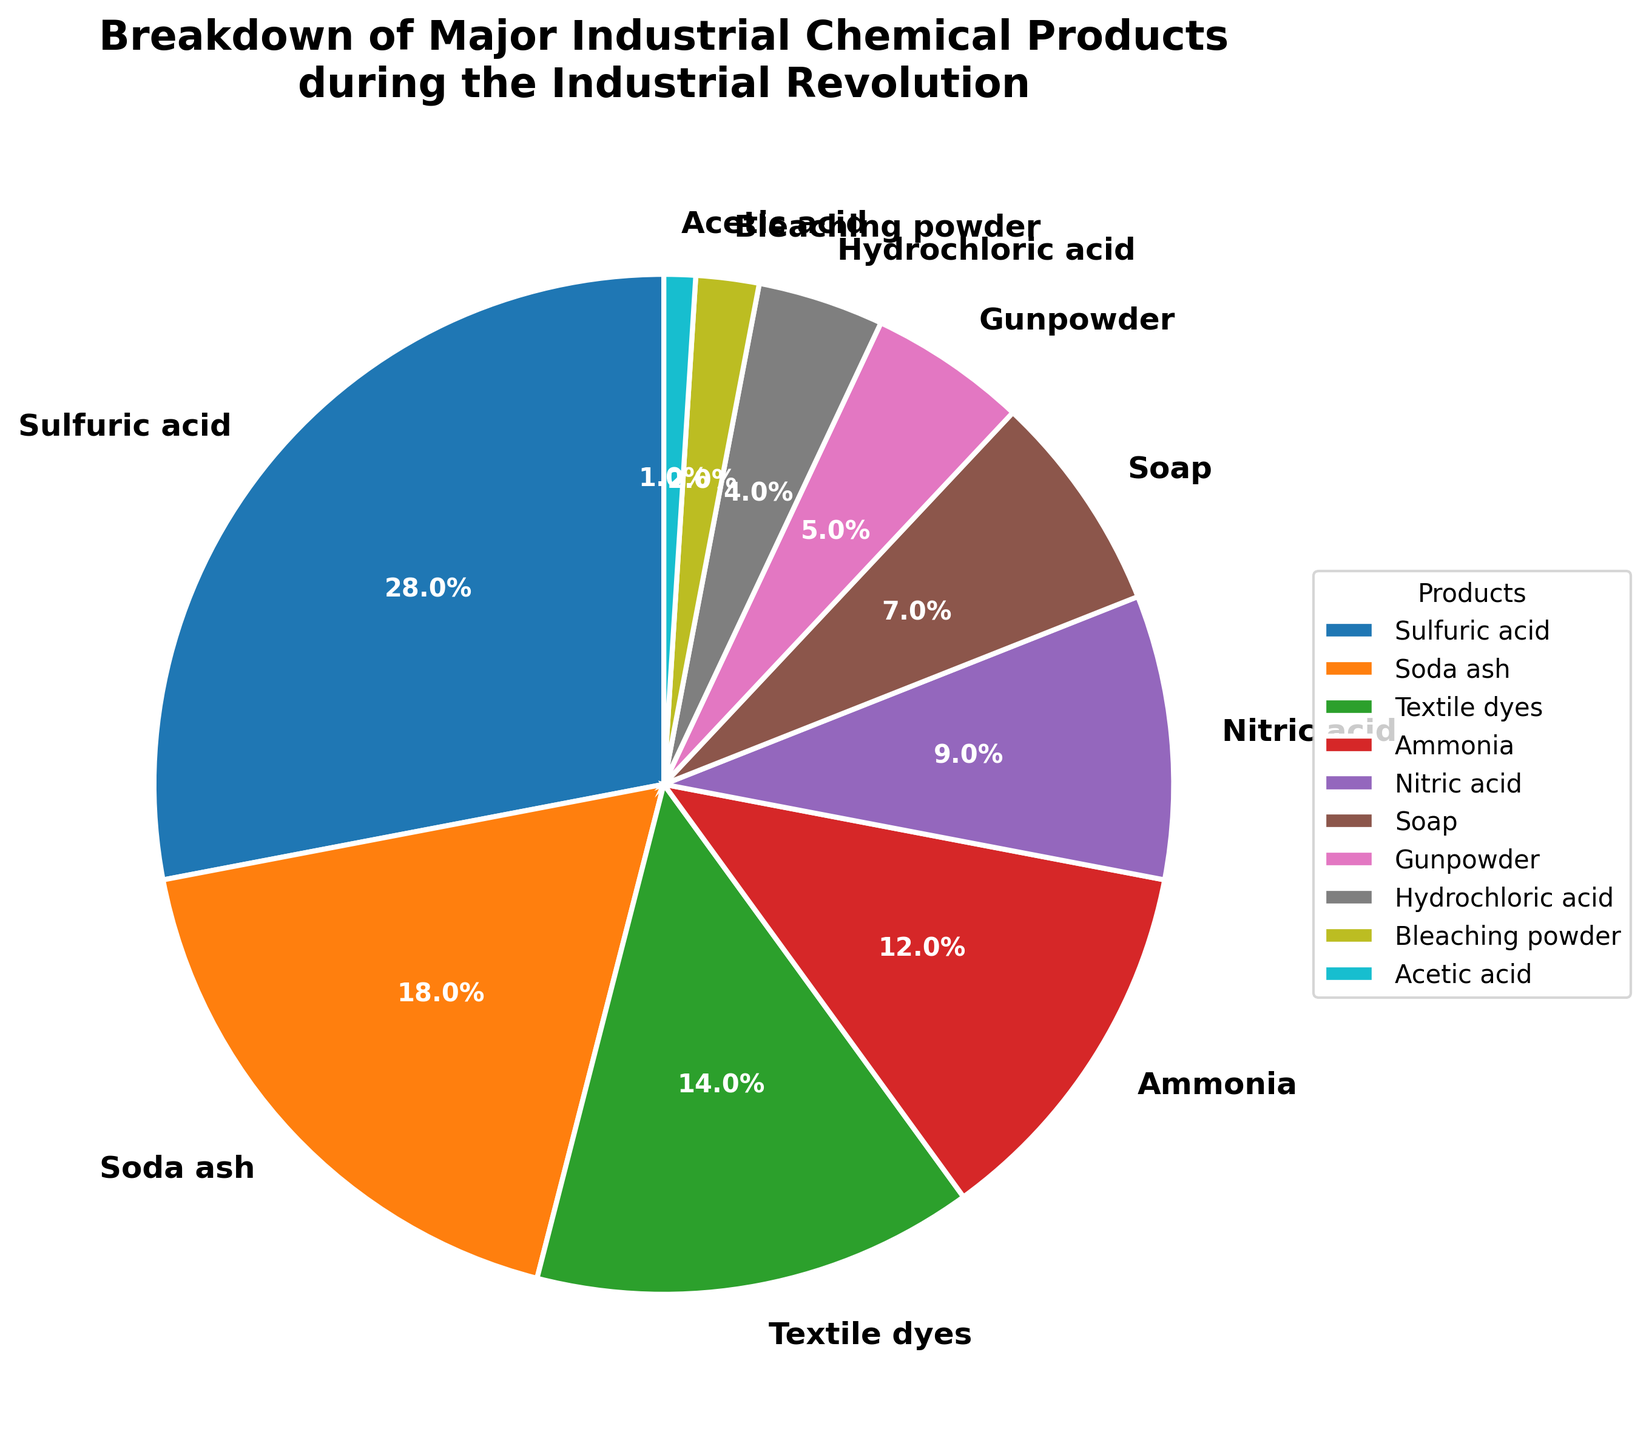What's the largest chemical product category by percentage? The pie chart segments different industrial chemical products. By examining the segment sizes and labels, we see that Sulfuric acid has the largest segment.
Answer: Sulfuric acid What's the combined percentage of Soda ash and Soap? To find the combined percentage, add the percentages of Soda ash and Soap. According to the data, Soda ash is 18% and Soap is 7%, so 18 + 7 = 25%.
Answer: 25% Which product has a smaller percentage: Nitric acid or Textiles dyes? Compare the sizes of the segments labeled Nitric acid and Textile dyes. Nitric acid is 9% and Textile dyes is 14%.
Answer: Nitric acid How much greater is the percentage of Sulfuric acid compared to Ammonia? We need to subtract the percentage of Ammonia from Sulfuric acid. Sulfuric acid is 28% and Ammonia is 12%, so 28 - 12 = 16%.
Answer: 16% What's the percentage range covered by the three least common chemical products? Identify the three least common products and note their percentages: Acetic acid (1%), Bleaching powder (2%), and Hydrochloric acid (4%). The range is from 1% to 4%.
Answer: 1% to 4% What's the total percentage of all products related to acids (Sulfuric acid, Nitric acid, Hydrochloric acid, and Acetic acid)? Sum the percentages of all the acid-related products: Sulfuric acid (28%), Nitric acid (9%), Hydrochloric acid (4%), and Acetic acid (1%). Total = 28 + 9 + 4 + 1 = 42%.
Answer: 42% Which product category has a percentage closest to 10%? Examine the percentage values and find the one closest to 10%. Ammonia has a percentage of 12%, which is the closest to 10%.
Answer: Ammonia Among the top three products, which one has the smallest percentage? The top three products are Sulfuric acid (28%), Soda ash (18%), and Textile dyes (14%). Textile dyes have the smallest percentage of the three.
Answer: Textile dyes 